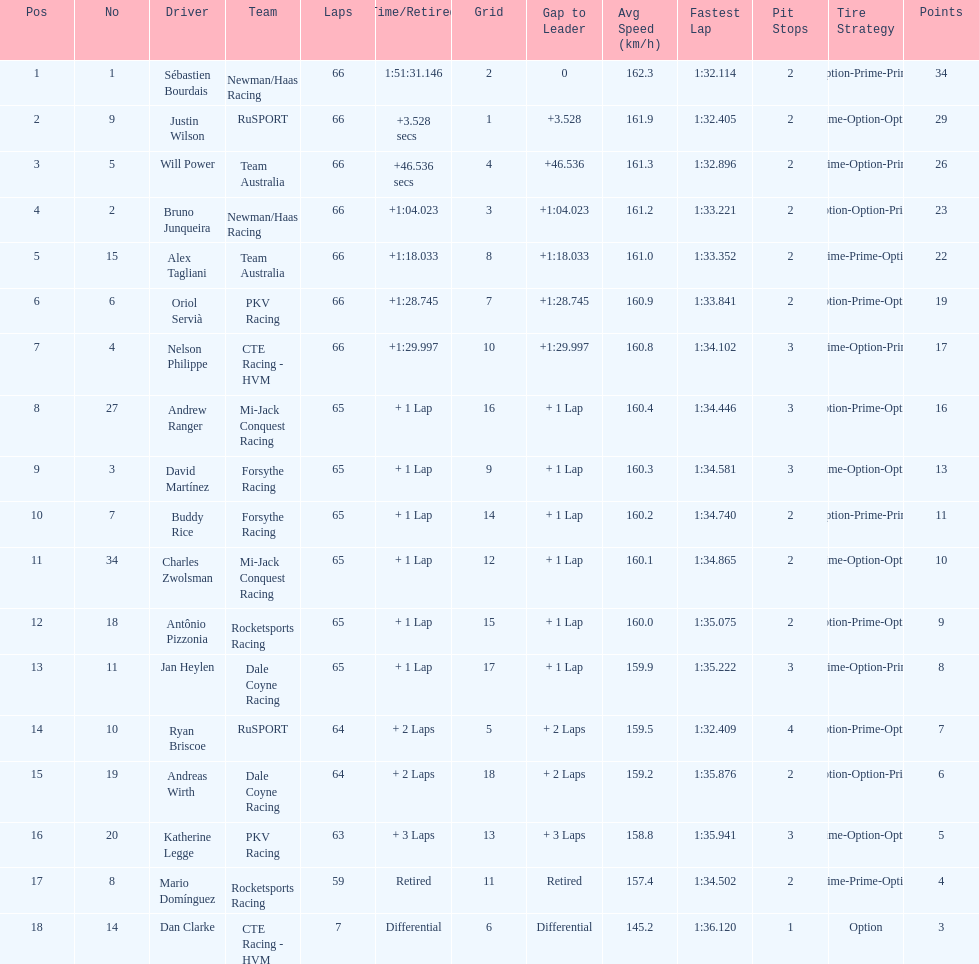Parse the table in full. {'header': ['Pos', 'No', 'Driver', 'Team', 'Laps', 'Time/Retired', 'Grid', 'Gap to Leader', 'Avg Speed (km/h)', 'Fastest Lap', 'Pit Stops', 'Tire Strategy', 'Points'], 'rows': [['1', '1', 'Sébastien Bourdais', 'Newman/Haas Racing', '66', '1:51:31.146', '2', '0', '162.3', '1:32.114', '2', 'Option-Prime-Prime', '34'], ['2', '9', 'Justin Wilson', 'RuSPORT', '66', '+3.528 secs', '1', '+3.528', '161.9', '1:32.405', '2', 'Prime-Option-Option', '29'], ['3', '5', 'Will Power', 'Team Australia', '66', '+46.536 secs', '4', '+46.536', '161.3', '1:32.896', '2', 'Prime-Option-Prime', '26'], ['4', '2', 'Bruno Junqueira', 'Newman/Haas Racing', '66', '+1:04.023', '3', '+1:04.023', '161.2', '1:33.221', '2', 'Option-Option-Prime', '23'], ['5', '15', 'Alex Tagliani', 'Team Australia', '66', '+1:18.033', '8', '+1:18.033', '161.0', '1:33.352', '2', 'Prime-Prime-Option', '22'], ['6', '6', 'Oriol Servià', 'PKV Racing', '66', '+1:28.745', '7', '+1:28.745', '160.9', '1:33.841', '2', 'Option-Prime-Option', '19'], ['7', '4', 'Nelson Philippe', 'CTE Racing - HVM', '66', '+1:29.997', '10', '+1:29.997', '160.8', '1:34.102', '3', 'Prime-Option-Prime', '17'], ['8', '27', 'Andrew Ranger', 'Mi-Jack Conquest Racing', '65', '+ 1 Lap', '16', '+ 1 Lap', '160.4', '1:34.446', '3', 'Option-Prime-Option', '16'], ['9', '3', 'David Martínez', 'Forsythe Racing', '65', '+ 1 Lap', '9', '+ 1 Lap', '160.3', '1:34.581', '3', 'Prime-Option-Option', '13'], ['10', '7', 'Buddy Rice', 'Forsythe Racing', '65', '+ 1 Lap', '14', '+ 1 Lap', '160.2', '1:34.740', '2', 'Option-Prime-Prime', '11'], ['11', '34', 'Charles Zwolsman', 'Mi-Jack Conquest Racing', '65', '+ 1 Lap', '12', '+ 1 Lap', '160.1', '1:34.865', '2', 'Prime-Option-Option', '10'], ['12', '18', 'Antônio Pizzonia', 'Rocketsports Racing', '65', '+ 1 Lap', '15', '+ 1 Lap', '160.0', '1:35.075', '2', 'Option-Prime-Option', '9'], ['13', '11', 'Jan Heylen', 'Dale Coyne Racing', '65', '+ 1 Lap', '17', '+ 1 Lap', '159.9', '1:35.222', '3', 'Prime-Option-Prime', '8'], ['14', '10', 'Ryan Briscoe', 'RuSPORT', '64', '+ 2 Laps', '5', '+ 2 Laps', '159.5', '1:32.409', '4', 'Option-Prime-Option', '7'], ['15', '19', 'Andreas Wirth', 'Dale Coyne Racing', '64', '+ 2 Laps', '18', '+ 2 Laps', '159.2', '1:35.876', '2', 'Option-Option-Prime', '6'], ['16', '20', 'Katherine Legge', 'PKV Racing', '63', '+ 3 Laps', '13', '+ 3 Laps', '158.8', '1:35.941', '3', 'Prime-Option-Option', '5'], ['17', '8', 'Mario Domínguez', 'Rocketsports Racing', '59', 'Retired', '11', 'Retired', '157.4', '1:34.502', '2', 'Prime-Prime-Option', '4'], ['18', '14', 'Dan Clarke', 'CTE Racing - HVM', '7', 'Differential', '6', 'Differential', '145.2', '1:36.120', '1', 'Option', '3']]} Which driver has the same number as his/her position? Sébastien Bourdais. 